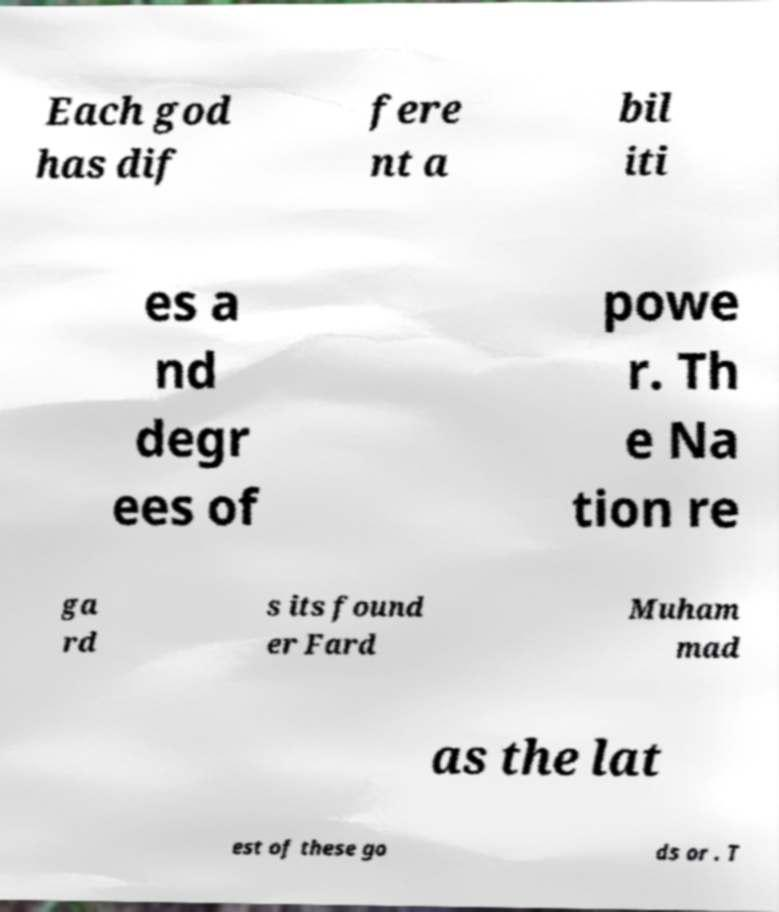Please identify and transcribe the text found in this image. Each god has dif fere nt a bil iti es a nd degr ees of powe r. Th e Na tion re ga rd s its found er Fard Muham mad as the lat est of these go ds or . T 